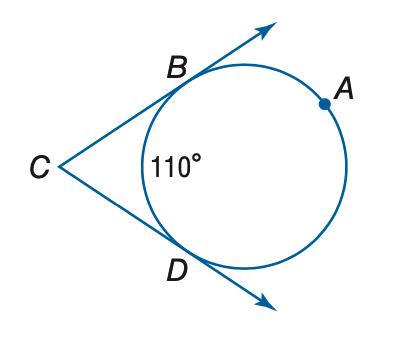Answer the mathemtical geometry problem and directly provide the correct option letter.
Question: Find the measure of m \angle C.
Choices: A: 35 B: 70 C: 90 D: 140 B 